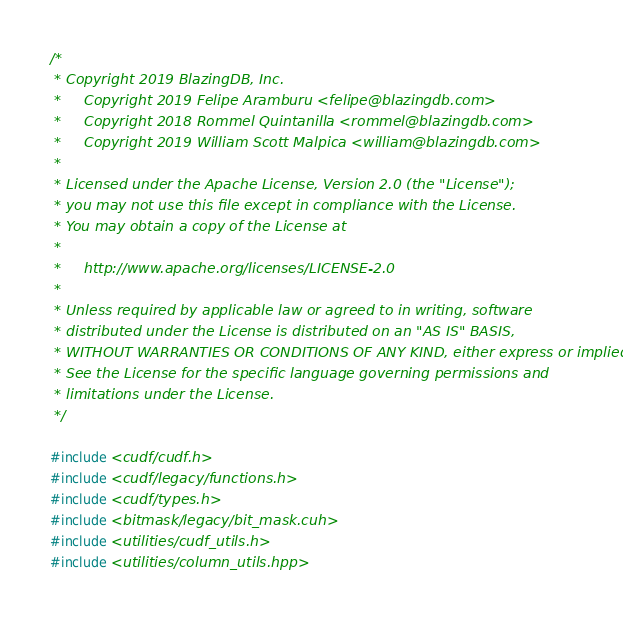Convert code to text. <code><loc_0><loc_0><loc_500><loc_500><_Cuda_>/*
 * Copyright 2019 BlazingDB, Inc.
 *     Copyright 2019 Felipe Aramburu <felipe@blazingdb.com>
 *     Copyright 2018 Rommel Quintanilla <rommel@blazingdb.com>
 *     Copyright 2019 William Scott Malpica <william@blazingdb.com>
 *
 * Licensed under the Apache License, Version 2.0 (the "License");
 * you may not use this file except in compliance with the License.
 * You may obtain a copy of the License at
 *
 *     http://www.apache.org/licenses/LICENSE-2.0
 *
 * Unless required by applicable law or agreed to in writing, software
 * distributed under the License is distributed on an "AS IS" BASIS,
 * WITHOUT WARRANTIES OR CONDITIONS OF ANY KIND, either express or implied.
 * See the License for the specific language governing permissions and
 * limitations under the License.
 */

#include <cudf/cudf.h>
#include <cudf/legacy/functions.h>
#include <cudf/types.h>
#include <bitmask/legacy/bit_mask.cuh>
#include <utilities/cudf_utils.h>
#include <utilities/column_utils.hpp>
</code> 